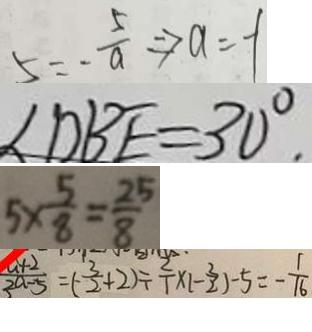<formula> <loc_0><loc_0><loc_500><loc_500>5 = - \frac { 5 } { a } \Rightarrow a = - 1 
 \angle D B E = 3 0 ^ { \circ } 
 5 \times \frac { 5 } { 8 } = \frac { 2 5 } { 8 } 
 \frac { a + 2 } { 2 a - 5 } = ( - \frac { 3 } { 2 } + 2 ) \div \frac { 2 } { 1 } \times 1 - \frac { 3 } { 2 } ) - 5 = - \frac { 1 } { 1 6 }</formula> 